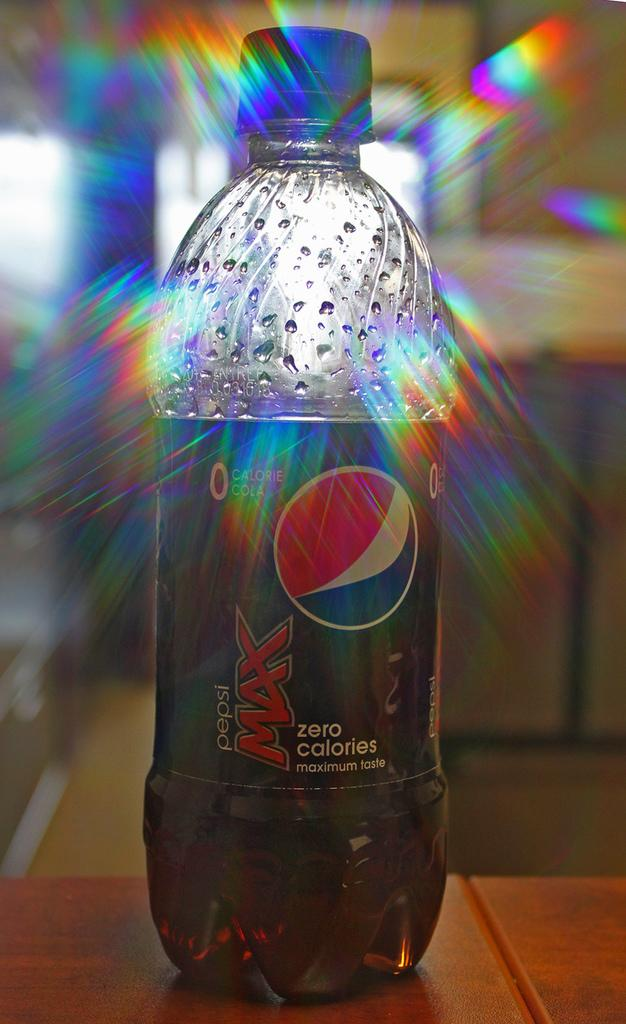<image>
Provide a brief description of the given image. A bottle of Pepsi sparkles in the sun. 